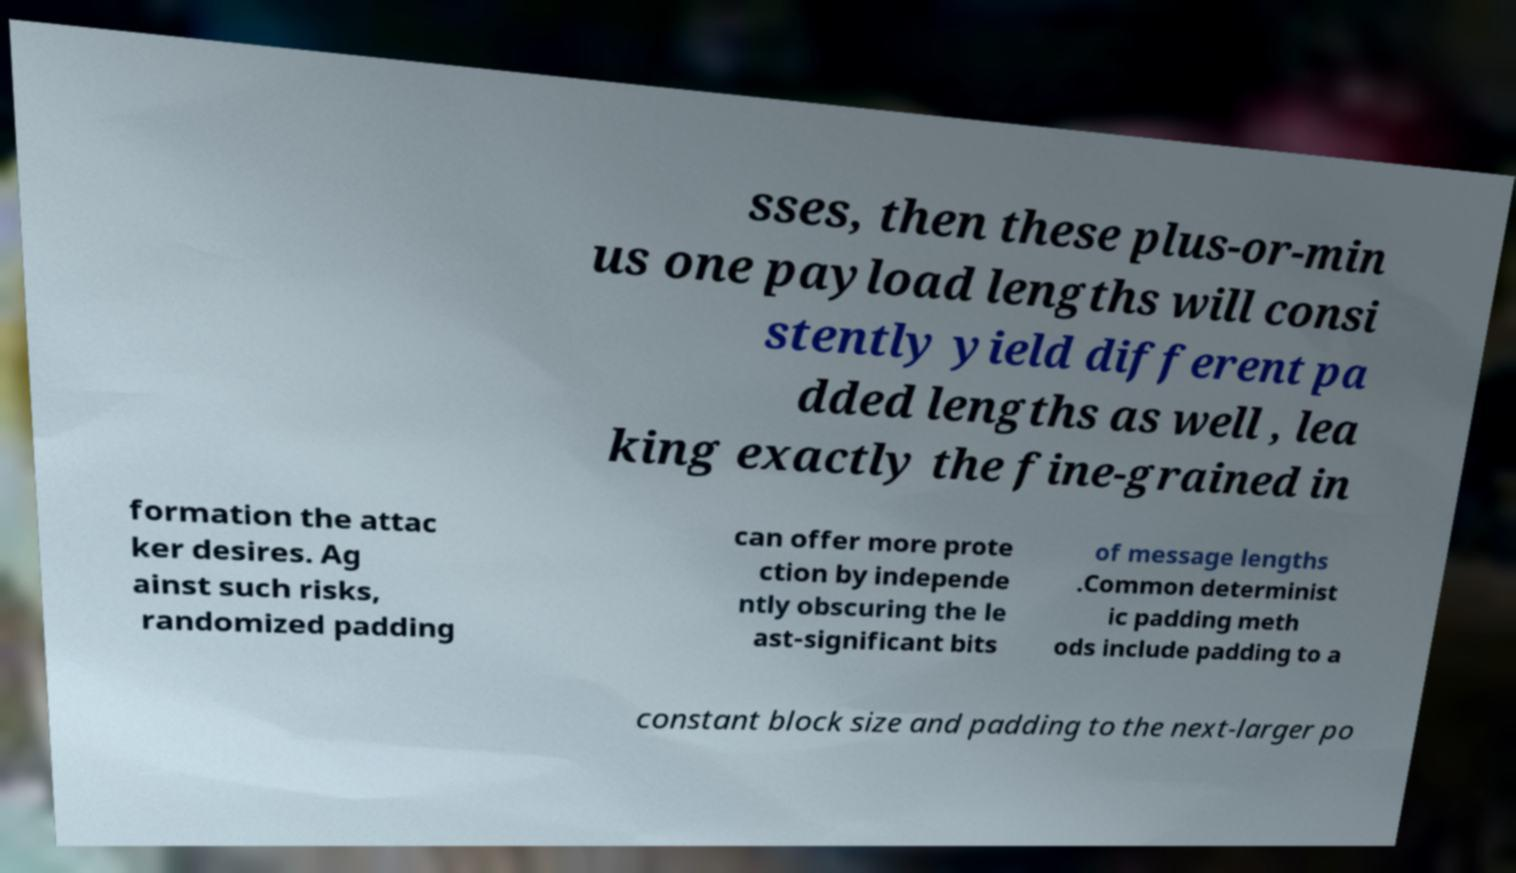Could you extract and type out the text from this image? sses, then these plus-or-min us one payload lengths will consi stently yield different pa dded lengths as well , lea king exactly the fine-grained in formation the attac ker desires. Ag ainst such risks, randomized padding can offer more prote ction by independe ntly obscuring the le ast-significant bits of message lengths .Common determinist ic padding meth ods include padding to a constant block size and padding to the next-larger po 